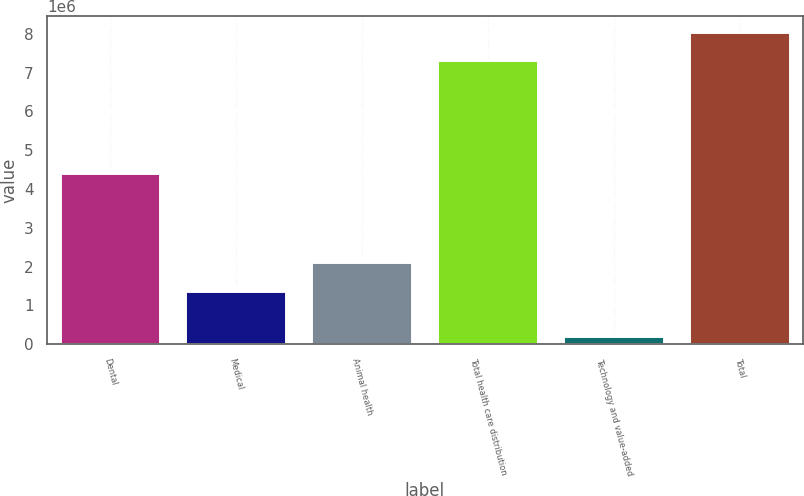Convert chart to OTSL. <chart><loc_0><loc_0><loc_500><loc_500><bar_chart><fcel>Dental<fcel>Medical<fcel>Animal health<fcel>Total health care distribution<fcel>Technology and value-added<fcel>Total<nl><fcel>4.41547e+06<fcel>1.374e+06<fcel>2.10668e+06<fcel>7.32684e+06<fcel>199952<fcel>8.05952e+06<nl></chart> 